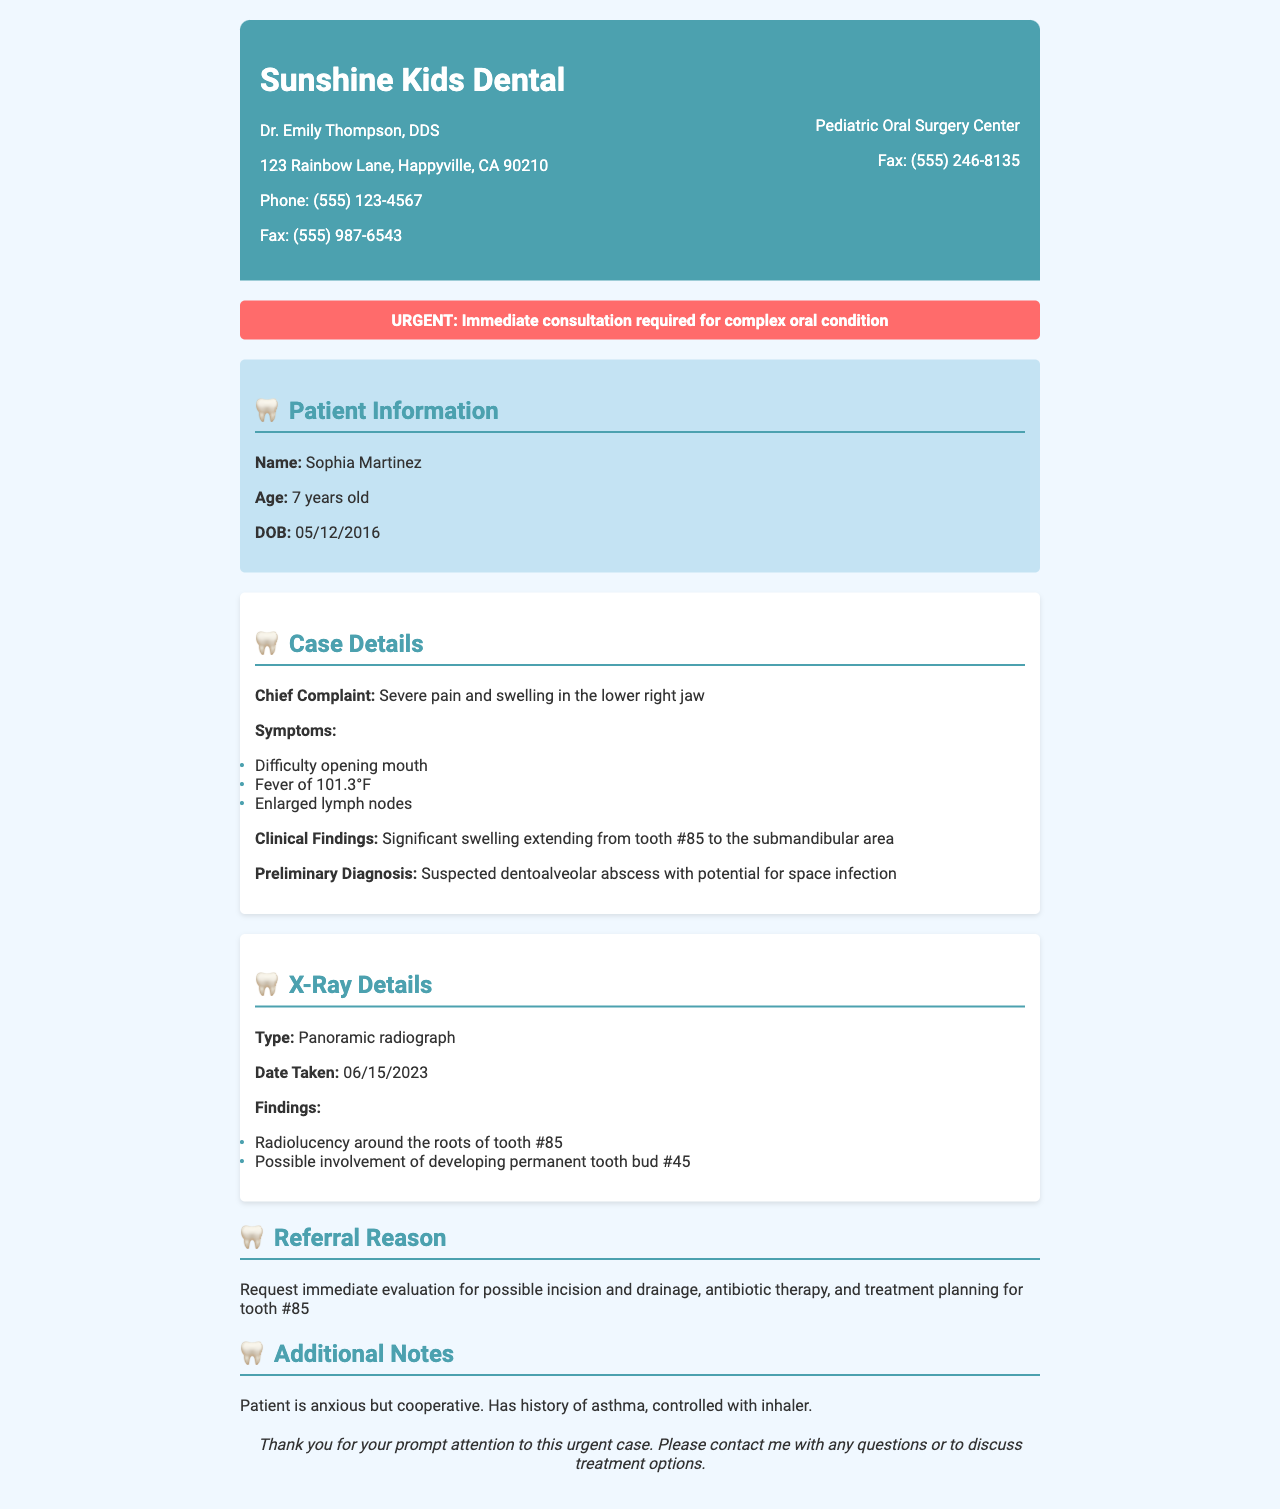What is the patient's name? The patient's name is provided in the patient information section.
Answer: Sophia Martinez How old is Sophia? The age of the patient is mentioned explicitly under patient information.
Answer: 7 years old What is the chief complaint? The chief complaint is stated clearly in the case details section of the document.
Answer: Severe pain and swelling in the lower right jaw What is the preliminary diagnosis? The preliminary diagnosis can be found in the case details section.
Answer: Suspected dentoalveolar abscess with potential for space infection What is the type of X-ray taken? The type of X-ray is explicitly mentioned in the X-ray details section.
Answer: Panoramic radiograph When was the X-ray taken? The date the X-ray was taken is given in the X-ray details.
Answer: 06/15/2023 What are the findings related to tooth #85? The findings regarding tooth #85 are listed in the X-ray details section.
Answer: Radiolucency around the roots of tooth #85 What is the reason for referral? The reason for referral is stated in the referral reason section of the document.
Answer: Request immediate evaluation for possible incision and drainage Is the patient cooperative? Information about the patient's behavior is provided in the additional notes.
Answer: Cooperative What is the history of the patient? The patient's history details are found in the additional notes section.
Answer: History of asthma, controlled with inhaler 